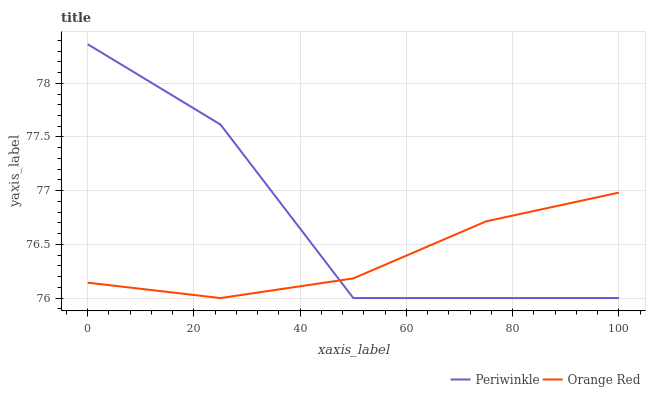Does Orange Red have the minimum area under the curve?
Answer yes or no. Yes. Does Periwinkle have the maximum area under the curve?
Answer yes or no. Yes. Does Orange Red have the maximum area under the curve?
Answer yes or no. No. Is Orange Red the smoothest?
Answer yes or no. Yes. Is Periwinkle the roughest?
Answer yes or no. Yes. Is Orange Red the roughest?
Answer yes or no. No. Does Periwinkle have the lowest value?
Answer yes or no. Yes. Does Periwinkle have the highest value?
Answer yes or no. Yes. Does Orange Red have the highest value?
Answer yes or no. No. Does Periwinkle intersect Orange Red?
Answer yes or no. Yes. Is Periwinkle less than Orange Red?
Answer yes or no. No. Is Periwinkle greater than Orange Red?
Answer yes or no. No. 